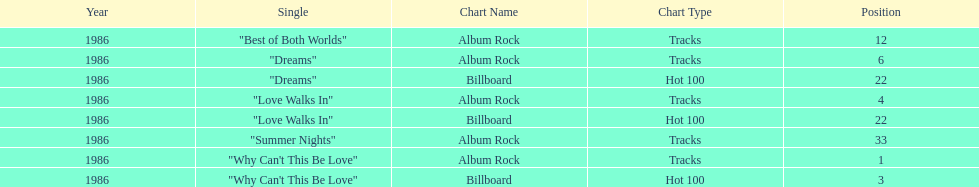Which is the most popular single on the album? Why Can't This Be Love. 